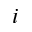<formula> <loc_0><loc_0><loc_500><loc_500>i</formula> 